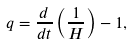Convert formula to latex. <formula><loc_0><loc_0><loc_500><loc_500>q = \frac { d } { d t } \left ( \frac { 1 } { H } \right ) - 1 ,</formula> 